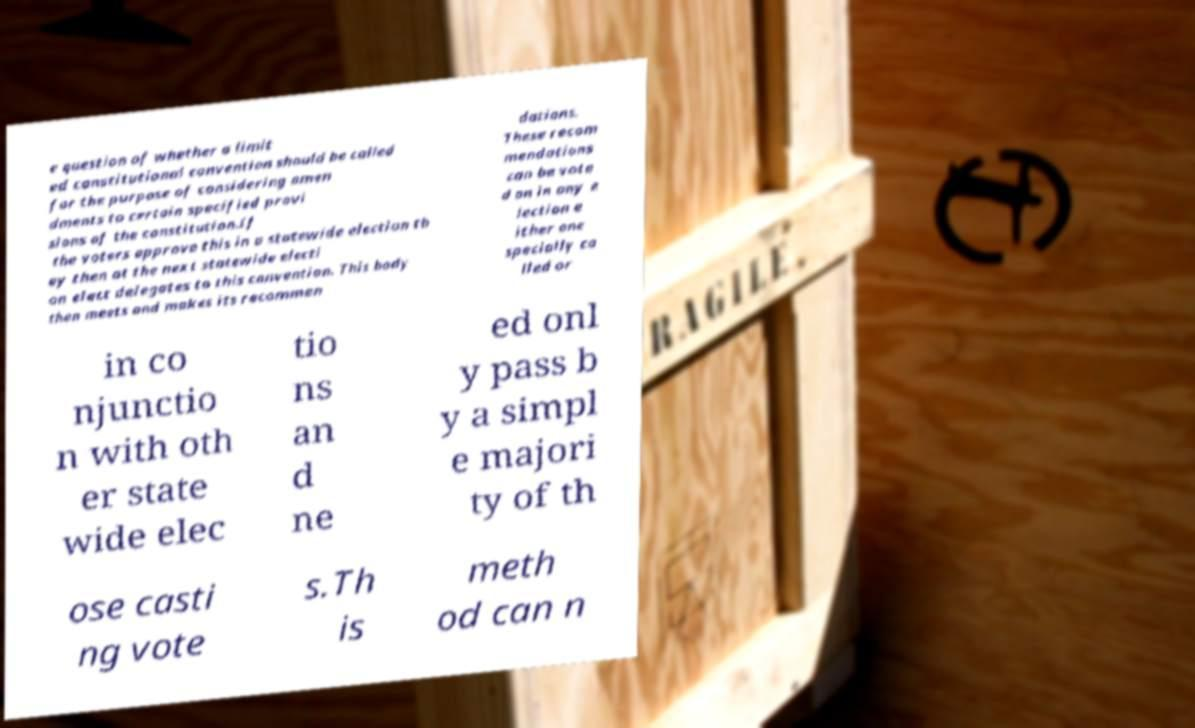Could you extract and type out the text from this image? e question of whether a limit ed constitutional convention should be called for the purpose of considering amen dments to certain specified provi sions of the constitution.If the voters approve this in a statewide election th ey then at the next statewide electi on elect delegates to this convention. This body then meets and makes its recommen dations. These recom mendations can be vote d on in any e lection e ither one specially ca lled or in co njunctio n with oth er state wide elec tio ns an d ne ed onl y pass b y a simpl e majori ty of th ose casti ng vote s.Th is meth od can n 